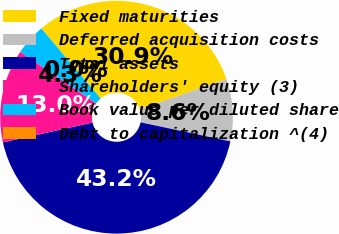Convert chart. <chart><loc_0><loc_0><loc_500><loc_500><pie_chart><fcel>Fixed maturities<fcel>Deferred acquisition costs<fcel>Total assets<fcel>Shareholders' equity (3)<fcel>Book value per diluted share<fcel>Debt to capitalization ^(4)<nl><fcel>30.88%<fcel>8.64%<fcel>43.2%<fcel>12.96%<fcel>4.32%<fcel>0.0%<nl></chart> 